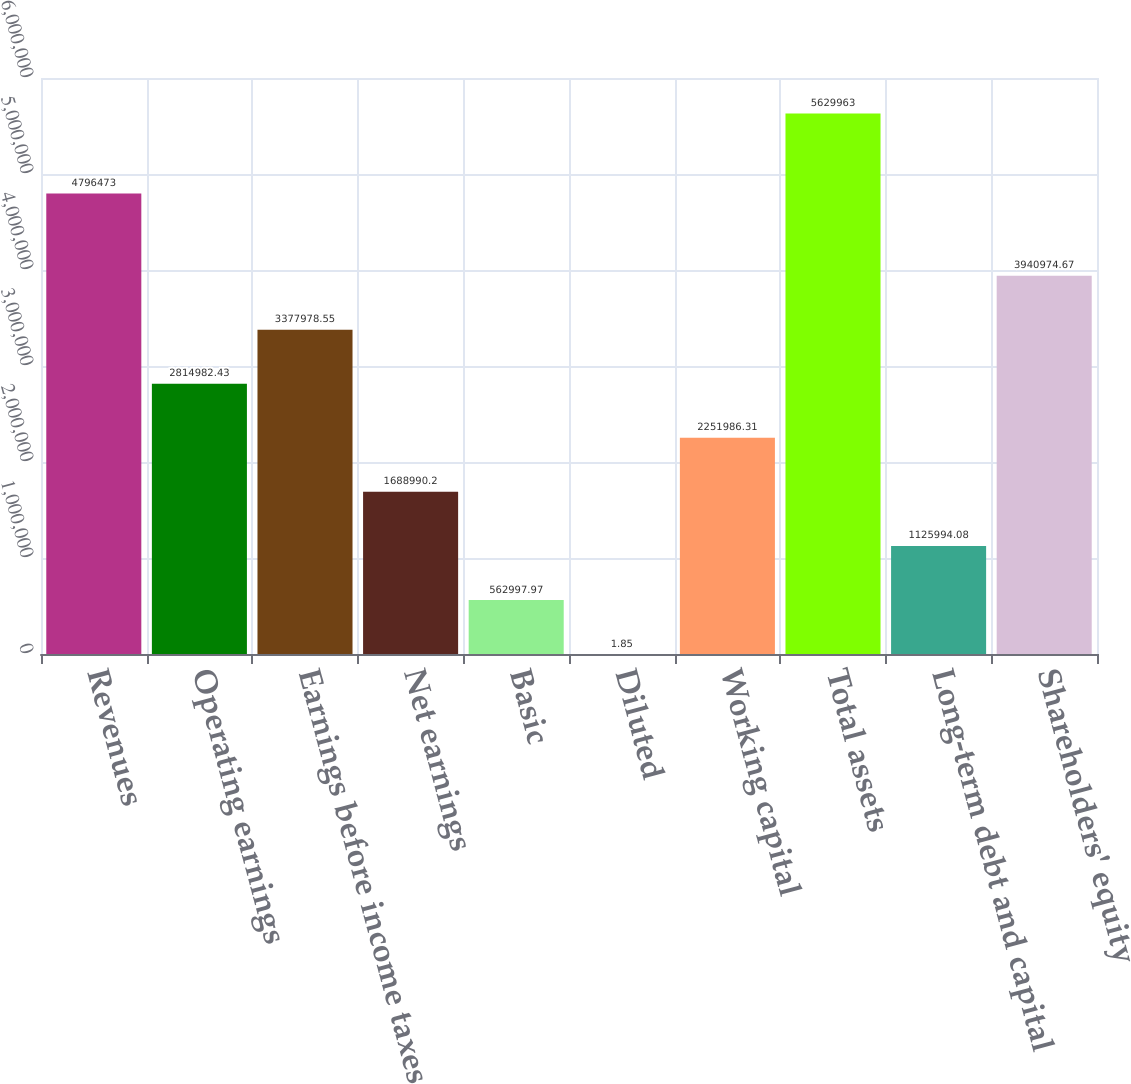Convert chart. <chart><loc_0><loc_0><loc_500><loc_500><bar_chart><fcel>Revenues<fcel>Operating earnings<fcel>Earnings before income taxes<fcel>Net earnings<fcel>Basic<fcel>Diluted<fcel>Working capital<fcel>Total assets<fcel>Long-term debt and capital<fcel>Shareholders' equity<nl><fcel>4.79647e+06<fcel>2.81498e+06<fcel>3.37798e+06<fcel>1.68899e+06<fcel>562998<fcel>1.85<fcel>2.25199e+06<fcel>5.62996e+06<fcel>1.12599e+06<fcel>3.94097e+06<nl></chart> 